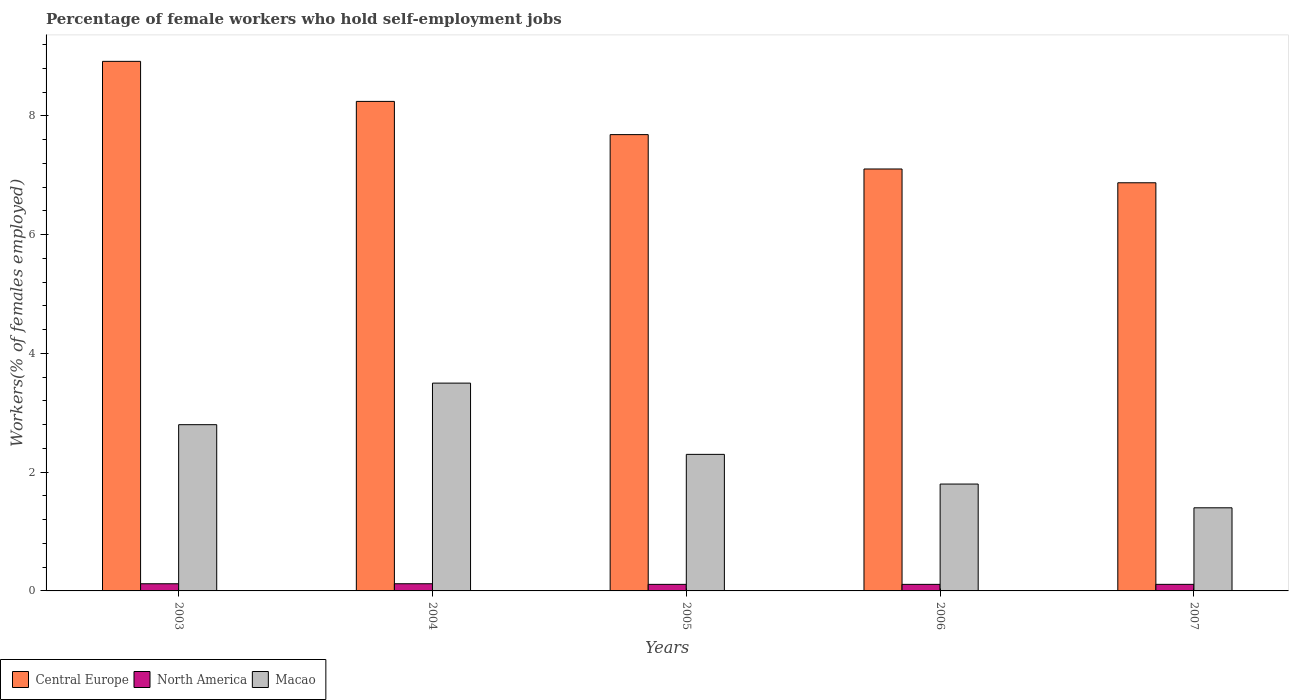How many different coloured bars are there?
Make the answer very short. 3. How many groups of bars are there?
Your answer should be very brief. 5. How many bars are there on the 5th tick from the right?
Make the answer very short. 3. What is the percentage of self-employed female workers in Macao in 2004?
Your answer should be very brief. 3.5. Across all years, what is the maximum percentage of self-employed female workers in Central Europe?
Give a very brief answer. 8.92. Across all years, what is the minimum percentage of self-employed female workers in Central Europe?
Give a very brief answer. 6.87. In which year was the percentage of self-employed female workers in Macao minimum?
Your answer should be compact. 2007. What is the total percentage of self-employed female workers in North America in the graph?
Make the answer very short. 0.57. What is the difference between the percentage of self-employed female workers in North America in 2006 and that in 2007?
Give a very brief answer. -0. What is the difference between the percentage of self-employed female workers in North America in 2006 and the percentage of self-employed female workers in Macao in 2004?
Provide a short and direct response. -3.39. What is the average percentage of self-employed female workers in North America per year?
Ensure brevity in your answer.  0.11. In the year 2005, what is the difference between the percentage of self-employed female workers in Central Europe and percentage of self-employed female workers in Macao?
Your response must be concise. 5.39. In how many years, is the percentage of self-employed female workers in Central Europe greater than 0.8 %?
Ensure brevity in your answer.  5. What is the ratio of the percentage of self-employed female workers in Central Europe in 2005 to that in 2007?
Give a very brief answer. 1.12. What is the difference between the highest and the second highest percentage of self-employed female workers in Central Europe?
Your answer should be compact. 0.67. What is the difference between the highest and the lowest percentage of self-employed female workers in Central Europe?
Your answer should be compact. 2.05. In how many years, is the percentage of self-employed female workers in Central Europe greater than the average percentage of self-employed female workers in Central Europe taken over all years?
Your answer should be compact. 2. Is the sum of the percentage of self-employed female workers in Macao in 2005 and 2006 greater than the maximum percentage of self-employed female workers in Central Europe across all years?
Your answer should be very brief. No. What does the 1st bar from the left in 2006 represents?
Ensure brevity in your answer.  Central Europe. What does the 3rd bar from the right in 2003 represents?
Your answer should be very brief. Central Europe. How many bars are there?
Offer a terse response. 15. How many years are there in the graph?
Your answer should be compact. 5. What is the difference between two consecutive major ticks on the Y-axis?
Give a very brief answer. 2. Are the values on the major ticks of Y-axis written in scientific E-notation?
Give a very brief answer. No. Where does the legend appear in the graph?
Your answer should be compact. Bottom left. What is the title of the graph?
Your answer should be very brief. Percentage of female workers who hold self-employment jobs. Does "Honduras" appear as one of the legend labels in the graph?
Provide a succinct answer. No. What is the label or title of the X-axis?
Provide a succinct answer. Years. What is the label or title of the Y-axis?
Provide a short and direct response. Workers(% of females employed). What is the Workers(% of females employed) of Central Europe in 2003?
Provide a succinct answer. 8.92. What is the Workers(% of females employed) in North America in 2003?
Your response must be concise. 0.12. What is the Workers(% of females employed) in Macao in 2003?
Your answer should be compact. 2.8. What is the Workers(% of females employed) of Central Europe in 2004?
Provide a short and direct response. 8.24. What is the Workers(% of females employed) in North America in 2004?
Your response must be concise. 0.12. What is the Workers(% of females employed) of Central Europe in 2005?
Your answer should be very brief. 7.69. What is the Workers(% of females employed) in North America in 2005?
Ensure brevity in your answer.  0.11. What is the Workers(% of females employed) of Macao in 2005?
Give a very brief answer. 2.3. What is the Workers(% of females employed) of Central Europe in 2006?
Provide a short and direct response. 7.11. What is the Workers(% of females employed) in North America in 2006?
Your response must be concise. 0.11. What is the Workers(% of females employed) of Macao in 2006?
Provide a succinct answer. 1.8. What is the Workers(% of females employed) of Central Europe in 2007?
Your answer should be very brief. 6.87. What is the Workers(% of females employed) in North America in 2007?
Your answer should be very brief. 0.11. What is the Workers(% of females employed) of Macao in 2007?
Provide a short and direct response. 1.4. Across all years, what is the maximum Workers(% of females employed) in Central Europe?
Your response must be concise. 8.92. Across all years, what is the maximum Workers(% of females employed) of North America?
Keep it short and to the point. 0.12. Across all years, what is the minimum Workers(% of females employed) of Central Europe?
Your answer should be very brief. 6.87. Across all years, what is the minimum Workers(% of females employed) in North America?
Your answer should be very brief. 0.11. Across all years, what is the minimum Workers(% of females employed) of Macao?
Your answer should be very brief. 1.4. What is the total Workers(% of females employed) in Central Europe in the graph?
Give a very brief answer. 38.83. What is the total Workers(% of females employed) of North America in the graph?
Your answer should be very brief. 0.57. What is the difference between the Workers(% of females employed) of Central Europe in 2003 and that in 2004?
Ensure brevity in your answer.  0.67. What is the difference between the Workers(% of females employed) in North America in 2003 and that in 2004?
Your answer should be very brief. -0. What is the difference between the Workers(% of females employed) in Central Europe in 2003 and that in 2005?
Give a very brief answer. 1.23. What is the difference between the Workers(% of females employed) in North America in 2003 and that in 2005?
Provide a short and direct response. 0.01. What is the difference between the Workers(% of females employed) of Central Europe in 2003 and that in 2006?
Your answer should be compact. 1.81. What is the difference between the Workers(% of females employed) in North America in 2003 and that in 2006?
Provide a short and direct response. 0.01. What is the difference between the Workers(% of females employed) in Macao in 2003 and that in 2006?
Offer a very short reply. 1. What is the difference between the Workers(% of females employed) of Central Europe in 2003 and that in 2007?
Your answer should be compact. 2.05. What is the difference between the Workers(% of females employed) of North America in 2003 and that in 2007?
Your answer should be compact. 0.01. What is the difference between the Workers(% of females employed) in Macao in 2003 and that in 2007?
Provide a short and direct response. 1.4. What is the difference between the Workers(% of females employed) in Central Europe in 2004 and that in 2005?
Offer a terse response. 0.56. What is the difference between the Workers(% of females employed) in North America in 2004 and that in 2005?
Make the answer very short. 0.01. What is the difference between the Workers(% of females employed) in Macao in 2004 and that in 2005?
Make the answer very short. 1.2. What is the difference between the Workers(% of females employed) of Central Europe in 2004 and that in 2006?
Your answer should be compact. 1.14. What is the difference between the Workers(% of females employed) in North America in 2004 and that in 2006?
Provide a succinct answer. 0.01. What is the difference between the Workers(% of females employed) of Central Europe in 2004 and that in 2007?
Offer a very short reply. 1.37. What is the difference between the Workers(% of females employed) of North America in 2004 and that in 2007?
Your answer should be compact. 0.01. What is the difference between the Workers(% of females employed) of Central Europe in 2005 and that in 2006?
Your answer should be very brief. 0.58. What is the difference between the Workers(% of females employed) of Central Europe in 2005 and that in 2007?
Your answer should be very brief. 0.81. What is the difference between the Workers(% of females employed) in North America in 2005 and that in 2007?
Provide a short and direct response. -0. What is the difference between the Workers(% of females employed) of Macao in 2005 and that in 2007?
Provide a succinct answer. 0.9. What is the difference between the Workers(% of females employed) of Central Europe in 2006 and that in 2007?
Your answer should be compact. 0.23. What is the difference between the Workers(% of females employed) in North America in 2006 and that in 2007?
Provide a short and direct response. -0. What is the difference between the Workers(% of females employed) in Central Europe in 2003 and the Workers(% of females employed) in North America in 2004?
Provide a short and direct response. 8.8. What is the difference between the Workers(% of females employed) in Central Europe in 2003 and the Workers(% of females employed) in Macao in 2004?
Your response must be concise. 5.42. What is the difference between the Workers(% of females employed) of North America in 2003 and the Workers(% of females employed) of Macao in 2004?
Provide a succinct answer. -3.38. What is the difference between the Workers(% of females employed) of Central Europe in 2003 and the Workers(% of females employed) of North America in 2005?
Your answer should be compact. 8.81. What is the difference between the Workers(% of females employed) in Central Europe in 2003 and the Workers(% of females employed) in Macao in 2005?
Your response must be concise. 6.62. What is the difference between the Workers(% of females employed) in North America in 2003 and the Workers(% of females employed) in Macao in 2005?
Make the answer very short. -2.18. What is the difference between the Workers(% of females employed) in Central Europe in 2003 and the Workers(% of females employed) in North America in 2006?
Keep it short and to the point. 8.81. What is the difference between the Workers(% of females employed) in Central Europe in 2003 and the Workers(% of females employed) in Macao in 2006?
Offer a terse response. 7.12. What is the difference between the Workers(% of females employed) in North America in 2003 and the Workers(% of females employed) in Macao in 2006?
Ensure brevity in your answer.  -1.68. What is the difference between the Workers(% of females employed) in Central Europe in 2003 and the Workers(% of females employed) in North America in 2007?
Ensure brevity in your answer.  8.81. What is the difference between the Workers(% of females employed) in Central Europe in 2003 and the Workers(% of females employed) in Macao in 2007?
Provide a succinct answer. 7.52. What is the difference between the Workers(% of females employed) in North America in 2003 and the Workers(% of females employed) in Macao in 2007?
Offer a terse response. -1.28. What is the difference between the Workers(% of females employed) in Central Europe in 2004 and the Workers(% of females employed) in North America in 2005?
Give a very brief answer. 8.13. What is the difference between the Workers(% of females employed) in Central Europe in 2004 and the Workers(% of females employed) in Macao in 2005?
Give a very brief answer. 5.94. What is the difference between the Workers(% of females employed) of North America in 2004 and the Workers(% of females employed) of Macao in 2005?
Give a very brief answer. -2.18. What is the difference between the Workers(% of females employed) in Central Europe in 2004 and the Workers(% of females employed) in North America in 2006?
Your response must be concise. 8.13. What is the difference between the Workers(% of females employed) in Central Europe in 2004 and the Workers(% of females employed) in Macao in 2006?
Give a very brief answer. 6.44. What is the difference between the Workers(% of females employed) of North America in 2004 and the Workers(% of females employed) of Macao in 2006?
Keep it short and to the point. -1.68. What is the difference between the Workers(% of females employed) in Central Europe in 2004 and the Workers(% of females employed) in North America in 2007?
Keep it short and to the point. 8.13. What is the difference between the Workers(% of females employed) of Central Europe in 2004 and the Workers(% of females employed) of Macao in 2007?
Ensure brevity in your answer.  6.84. What is the difference between the Workers(% of females employed) of North America in 2004 and the Workers(% of females employed) of Macao in 2007?
Offer a terse response. -1.28. What is the difference between the Workers(% of females employed) in Central Europe in 2005 and the Workers(% of females employed) in North America in 2006?
Your response must be concise. 7.57. What is the difference between the Workers(% of females employed) in Central Europe in 2005 and the Workers(% of females employed) in Macao in 2006?
Provide a short and direct response. 5.89. What is the difference between the Workers(% of females employed) of North America in 2005 and the Workers(% of females employed) of Macao in 2006?
Make the answer very short. -1.69. What is the difference between the Workers(% of females employed) in Central Europe in 2005 and the Workers(% of females employed) in North America in 2007?
Offer a very short reply. 7.57. What is the difference between the Workers(% of females employed) of Central Europe in 2005 and the Workers(% of females employed) of Macao in 2007?
Your response must be concise. 6.29. What is the difference between the Workers(% of females employed) of North America in 2005 and the Workers(% of females employed) of Macao in 2007?
Provide a short and direct response. -1.29. What is the difference between the Workers(% of females employed) in Central Europe in 2006 and the Workers(% of females employed) in North America in 2007?
Provide a succinct answer. 7. What is the difference between the Workers(% of females employed) of Central Europe in 2006 and the Workers(% of females employed) of Macao in 2007?
Offer a terse response. 5.71. What is the difference between the Workers(% of females employed) of North America in 2006 and the Workers(% of females employed) of Macao in 2007?
Offer a very short reply. -1.29. What is the average Workers(% of females employed) of Central Europe per year?
Make the answer very short. 7.77. What is the average Workers(% of females employed) of North America per year?
Provide a short and direct response. 0.11. What is the average Workers(% of females employed) of Macao per year?
Your response must be concise. 2.36. In the year 2003, what is the difference between the Workers(% of females employed) in Central Europe and Workers(% of females employed) in North America?
Keep it short and to the point. 8.8. In the year 2003, what is the difference between the Workers(% of females employed) in Central Europe and Workers(% of females employed) in Macao?
Ensure brevity in your answer.  6.12. In the year 2003, what is the difference between the Workers(% of females employed) of North America and Workers(% of females employed) of Macao?
Provide a short and direct response. -2.68. In the year 2004, what is the difference between the Workers(% of females employed) of Central Europe and Workers(% of females employed) of North America?
Give a very brief answer. 8.12. In the year 2004, what is the difference between the Workers(% of females employed) of Central Europe and Workers(% of females employed) of Macao?
Your answer should be compact. 4.74. In the year 2004, what is the difference between the Workers(% of females employed) in North America and Workers(% of females employed) in Macao?
Offer a very short reply. -3.38. In the year 2005, what is the difference between the Workers(% of females employed) of Central Europe and Workers(% of females employed) of North America?
Your answer should be very brief. 7.57. In the year 2005, what is the difference between the Workers(% of females employed) in Central Europe and Workers(% of females employed) in Macao?
Provide a short and direct response. 5.39. In the year 2005, what is the difference between the Workers(% of females employed) of North America and Workers(% of females employed) of Macao?
Ensure brevity in your answer.  -2.19. In the year 2006, what is the difference between the Workers(% of females employed) of Central Europe and Workers(% of females employed) of North America?
Your answer should be compact. 7. In the year 2006, what is the difference between the Workers(% of females employed) of Central Europe and Workers(% of females employed) of Macao?
Offer a very short reply. 5.31. In the year 2006, what is the difference between the Workers(% of females employed) in North America and Workers(% of females employed) in Macao?
Keep it short and to the point. -1.69. In the year 2007, what is the difference between the Workers(% of females employed) in Central Europe and Workers(% of females employed) in North America?
Offer a very short reply. 6.76. In the year 2007, what is the difference between the Workers(% of females employed) in Central Europe and Workers(% of females employed) in Macao?
Your answer should be compact. 5.47. In the year 2007, what is the difference between the Workers(% of females employed) of North America and Workers(% of females employed) of Macao?
Provide a succinct answer. -1.29. What is the ratio of the Workers(% of females employed) in Central Europe in 2003 to that in 2004?
Provide a succinct answer. 1.08. What is the ratio of the Workers(% of females employed) in Macao in 2003 to that in 2004?
Give a very brief answer. 0.8. What is the ratio of the Workers(% of females employed) of Central Europe in 2003 to that in 2005?
Give a very brief answer. 1.16. What is the ratio of the Workers(% of females employed) of North America in 2003 to that in 2005?
Provide a short and direct response. 1.09. What is the ratio of the Workers(% of females employed) in Macao in 2003 to that in 2005?
Provide a succinct answer. 1.22. What is the ratio of the Workers(% of females employed) in Central Europe in 2003 to that in 2006?
Offer a terse response. 1.26. What is the ratio of the Workers(% of females employed) in North America in 2003 to that in 2006?
Give a very brief answer. 1.09. What is the ratio of the Workers(% of females employed) in Macao in 2003 to that in 2006?
Your answer should be compact. 1.56. What is the ratio of the Workers(% of females employed) of Central Europe in 2003 to that in 2007?
Your answer should be very brief. 1.3. What is the ratio of the Workers(% of females employed) in North America in 2003 to that in 2007?
Offer a terse response. 1.09. What is the ratio of the Workers(% of females employed) of Central Europe in 2004 to that in 2005?
Your response must be concise. 1.07. What is the ratio of the Workers(% of females employed) of North America in 2004 to that in 2005?
Ensure brevity in your answer.  1.09. What is the ratio of the Workers(% of females employed) in Macao in 2004 to that in 2005?
Give a very brief answer. 1.52. What is the ratio of the Workers(% of females employed) of Central Europe in 2004 to that in 2006?
Offer a terse response. 1.16. What is the ratio of the Workers(% of females employed) in North America in 2004 to that in 2006?
Give a very brief answer. 1.09. What is the ratio of the Workers(% of females employed) of Macao in 2004 to that in 2006?
Provide a succinct answer. 1.94. What is the ratio of the Workers(% of females employed) in Central Europe in 2004 to that in 2007?
Make the answer very short. 1.2. What is the ratio of the Workers(% of females employed) in North America in 2004 to that in 2007?
Provide a succinct answer. 1.09. What is the ratio of the Workers(% of females employed) of Central Europe in 2005 to that in 2006?
Provide a short and direct response. 1.08. What is the ratio of the Workers(% of females employed) of North America in 2005 to that in 2006?
Keep it short and to the point. 1. What is the ratio of the Workers(% of females employed) in Macao in 2005 to that in 2006?
Keep it short and to the point. 1.28. What is the ratio of the Workers(% of females employed) in Central Europe in 2005 to that in 2007?
Keep it short and to the point. 1.12. What is the ratio of the Workers(% of females employed) in North America in 2005 to that in 2007?
Give a very brief answer. 1. What is the ratio of the Workers(% of females employed) of Macao in 2005 to that in 2007?
Offer a terse response. 1.64. What is the ratio of the Workers(% of females employed) of Central Europe in 2006 to that in 2007?
Your response must be concise. 1.03. What is the difference between the highest and the second highest Workers(% of females employed) in Central Europe?
Ensure brevity in your answer.  0.67. What is the difference between the highest and the second highest Workers(% of females employed) in Macao?
Your response must be concise. 0.7. What is the difference between the highest and the lowest Workers(% of females employed) in Central Europe?
Your answer should be compact. 2.05. What is the difference between the highest and the lowest Workers(% of females employed) of North America?
Your response must be concise. 0.01. What is the difference between the highest and the lowest Workers(% of females employed) of Macao?
Your response must be concise. 2.1. 